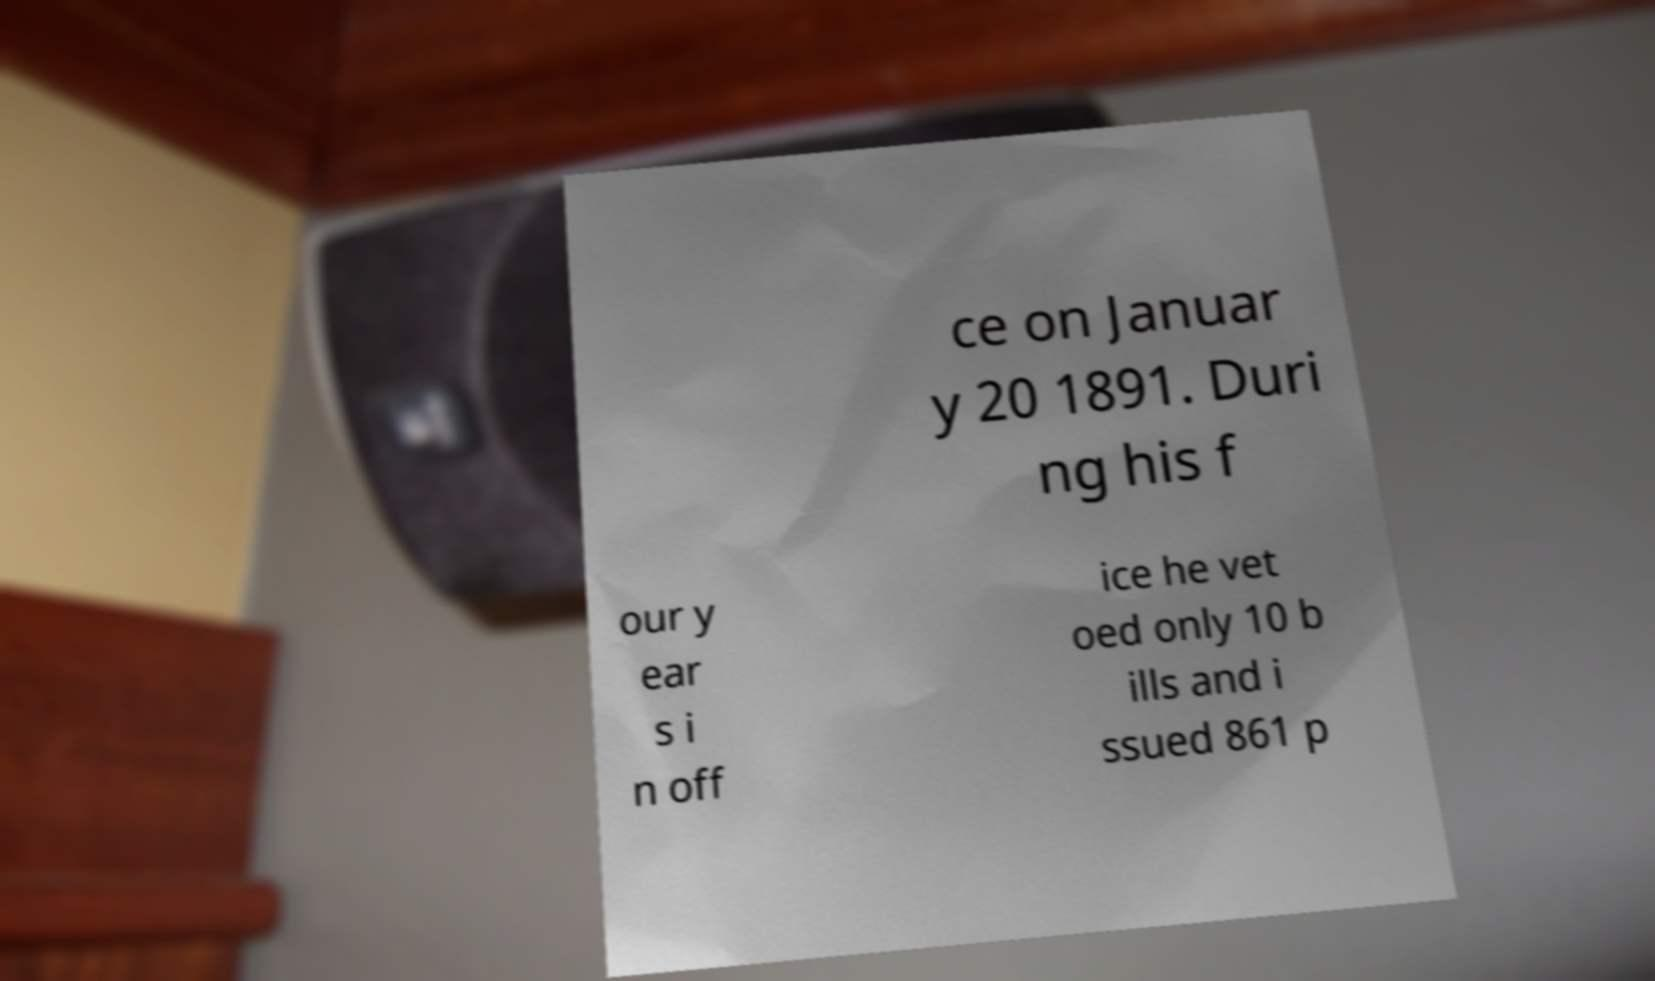Can you accurately transcribe the text from the provided image for me? ce on Januar y 20 1891. Duri ng his f our y ear s i n off ice he vet oed only 10 b ills and i ssued 861 p 